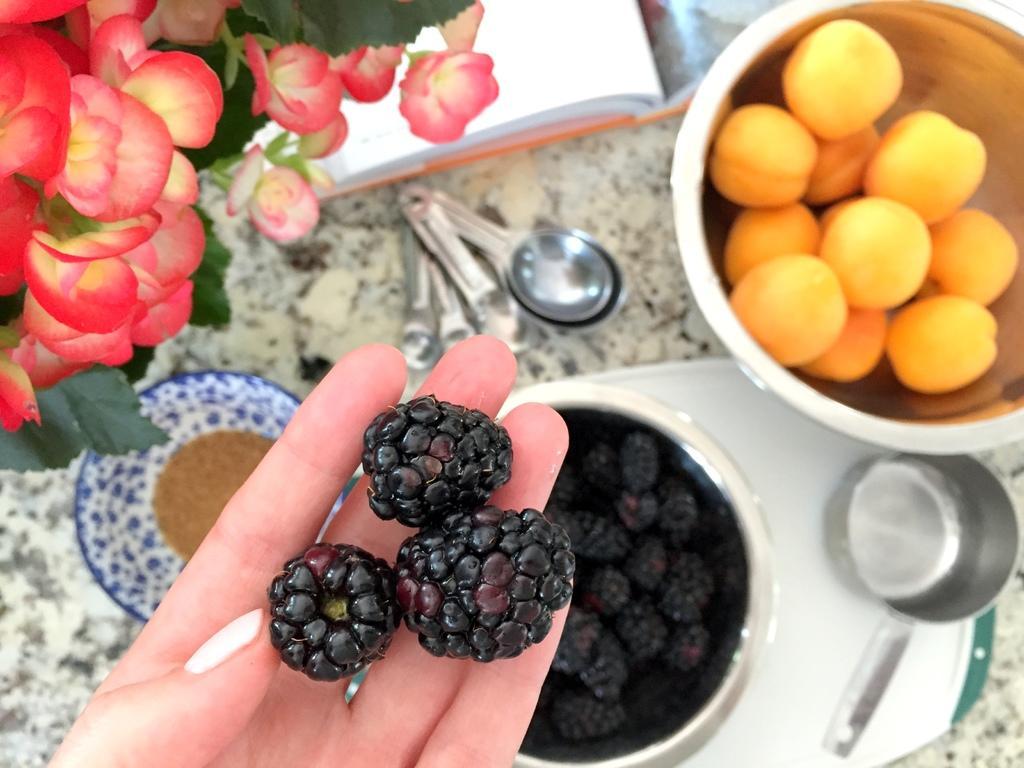Could you give a brief overview of what you see in this image? In this image there are black berries on a person hand, and there is a plant with flowers, bowl of blackberries and some food items, book, measuring spoon on the table. 